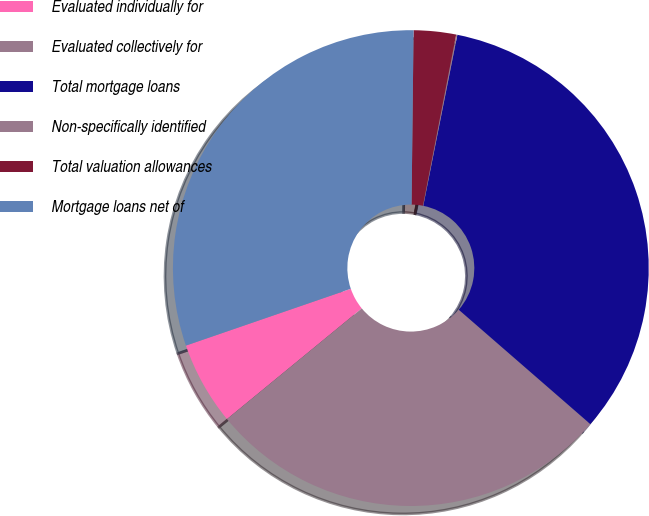<chart> <loc_0><loc_0><loc_500><loc_500><pie_chart><fcel>Evaluated individually for<fcel>Evaluated collectively for<fcel>Total mortgage loans<fcel>Non-specifically identified<fcel>Total valuation allowances<fcel>Mortgage loans net of<nl><fcel>5.66%<fcel>27.67%<fcel>33.25%<fcel>0.08%<fcel>2.87%<fcel>30.46%<nl></chart> 